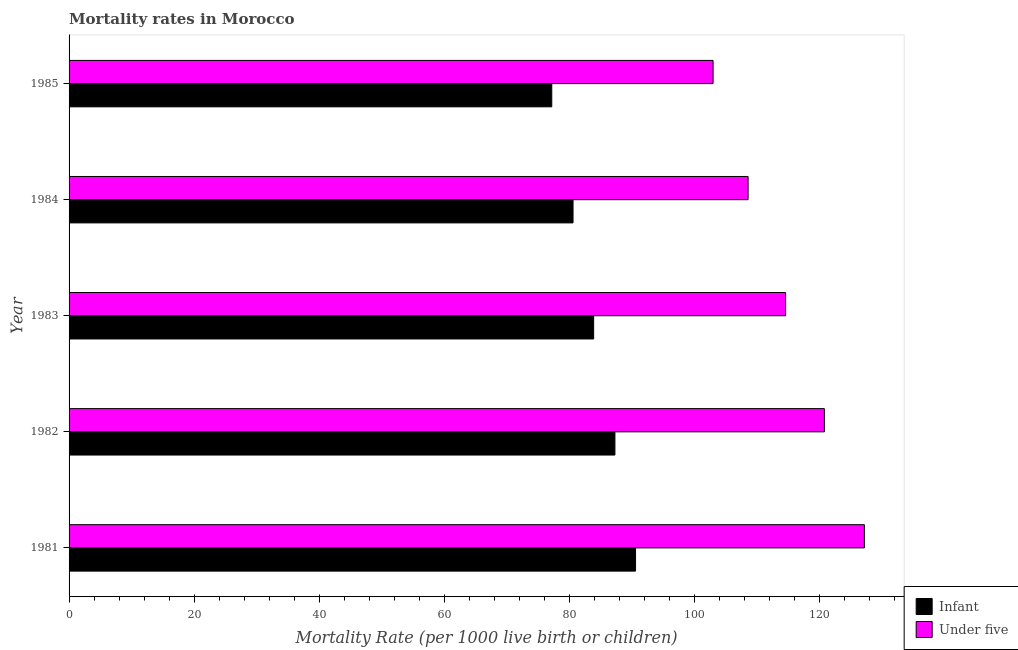Are the number of bars per tick equal to the number of legend labels?
Provide a succinct answer. Yes. Are the number of bars on each tick of the Y-axis equal?
Ensure brevity in your answer.  Yes. How many bars are there on the 2nd tick from the top?
Your response must be concise. 2. In how many cases, is the number of bars for a given year not equal to the number of legend labels?
Provide a short and direct response. 0. What is the under-5 mortality rate in 1985?
Keep it short and to the point. 103. Across all years, what is the maximum infant mortality rate?
Provide a succinct answer. 90.6. Across all years, what is the minimum infant mortality rate?
Offer a terse response. 77.2. In which year was the under-5 mortality rate minimum?
Make the answer very short. 1985. What is the total infant mortality rate in the graph?
Keep it short and to the point. 419.6. What is the difference between the infant mortality rate in 1981 and that in 1982?
Your response must be concise. 3.3. What is the difference between the under-5 mortality rate in 1984 and the infant mortality rate in 1983?
Your answer should be compact. 24.7. What is the average infant mortality rate per year?
Keep it short and to the point. 83.92. In the year 1985, what is the difference between the infant mortality rate and under-5 mortality rate?
Keep it short and to the point. -25.8. In how many years, is the infant mortality rate greater than 96 ?
Your response must be concise. 0. What is the ratio of the under-5 mortality rate in 1984 to that in 1985?
Offer a terse response. 1.05. Is the difference between the under-5 mortality rate in 1984 and 1985 greater than the difference between the infant mortality rate in 1984 and 1985?
Offer a very short reply. Yes. What is the difference between the highest and the second highest under-5 mortality rate?
Offer a very short reply. 6.4. What is the difference between the highest and the lowest under-5 mortality rate?
Keep it short and to the point. 24.2. Is the sum of the infant mortality rate in 1982 and 1985 greater than the maximum under-5 mortality rate across all years?
Provide a succinct answer. Yes. What does the 1st bar from the top in 1981 represents?
Offer a very short reply. Under five. What does the 2nd bar from the bottom in 1981 represents?
Your response must be concise. Under five. Are all the bars in the graph horizontal?
Keep it short and to the point. Yes. How many legend labels are there?
Keep it short and to the point. 2. What is the title of the graph?
Make the answer very short. Mortality rates in Morocco. Does "Male entrants" appear as one of the legend labels in the graph?
Give a very brief answer. No. What is the label or title of the X-axis?
Keep it short and to the point. Mortality Rate (per 1000 live birth or children). What is the label or title of the Y-axis?
Your answer should be very brief. Year. What is the Mortality Rate (per 1000 live birth or children) in Infant in 1981?
Your answer should be very brief. 90.6. What is the Mortality Rate (per 1000 live birth or children) of Under five in 1981?
Give a very brief answer. 127.2. What is the Mortality Rate (per 1000 live birth or children) in Infant in 1982?
Provide a succinct answer. 87.3. What is the Mortality Rate (per 1000 live birth or children) of Under five in 1982?
Make the answer very short. 120.8. What is the Mortality Rate (per 1000 live birth or children) of Infant in 1983?
Provide a succinct answer. 83.9. What is the Mortality Rate (per 1000 live birth or children) in Under five in 1983?
Your answer should be very brief. 114.6. What is the Mortality Rate (per 1000 live birth or children) of Infant in 1984?
Offer a terse response. 80.6. What is the Mortality Rate (per 1000 live birth or children) of Under five in 1984?
Your response must be concise. 108.6. What is the Mortality Rate (per 1000 live birth or children) in Infant in 1985?
Offer a very short reply. 77.2. What is the Mortality Rate (per 1000 live birth or children) in Under five in 1985?
Give a very brief answer. 103. Across all years, what is the maximum Mortality Rate (per 1000 live birth or children) of Infant?
Provide a succinct answer. 90.6. Across all years, what is the maximum Mortality Rate (per 1000 live birth or children) in Under five?
Your answer should be very brief. 127.2. Across all years, what is the minimum Mortality Rate (per 1000 live birth or children) of Infant?
Your answer should be very brief. 77.2. Across all years, what is the minimum Mortality Rate (per 1000 live birth or children) of Under five?
Keep it short and to the point. 103. What is the total Mortality Rate (per 1000 live birth or children) in Infant in the graph?
Provide a succinct answer. 419.6. What is the total Mortality Rate (per 1000 live birth or children) in Under five in the graph?
Offer a terse response. 574.2. What is the difference between the Mortality Rate (per 1000 live birth or children) of Under five in 1981 and that in 1982?
Your answer should be compact. 6.4. What is the difference between the Mortality Rate (per 1000 live birth or children) of Infant in 1981 and that in 1983?
Make the answer very short. 6.7. What is the difference between the Mortality Rate (per 1000 live birth or children) in Under five in 1981 and that in 1983?
Offer a terse response. 12.6. What is the difference between the Mortality Rate (per 1000 live birth or children) in Infant in 1981 and that in 1984?
Offer a very short reply. 10. What is the difference between the Mortality Rate (per 1000 live birth or children) in Infant in 1981 and that in 1985?
Your answer should be compact. 13.4. What is the difference between the Mortality Rate (per 1000 live birth or children) in Under five in 1981 and that in 1985?
Ensure brevity in your answer.  24.2. What is the difference between the Mortality Rate (per 1000 live birth or children) in Infant in 1982 and that in 1983?
Offer a very short reply. 3.4. What is the difference between the Mortality Rate (per 1000 live birth or children) of Under five in 1982 and that in 1983?
Your answer should be very brief. 6.2. What is the difference between the Mortality Rate (per 1000 live birth or children) in Infant in 1982 and that in 1985?
Keep it short and to the point. 10.1. What is the difference between the Mortality Rate (per 1000 live birth or children) of Under five in 1982 and that in 1985?
Offer a very short reply. 17.8. What is the difference between the Mortality Rate (per 1000 live birth or children) of Infant in 1983 and that in 1984?
Ensure brevity in your answer.  3.3. What is the difference between the Mortality Rate (per 1000 live birth or children) in Under five in 1983 and that in 1984?
Your response must be concise. 6. What is the difference between the Mortality Rate (per 1000 live birth or children) of Infant in 1983 and that in 1985?
Your response must be concise. 6.7. What is the difference between the Mortality Rate (per 1000 live birth or children) of Under five in 1983 and that in 1985?
Offer a very short reply. 11.6. What is the difference between the Mortality Rate (per 1000 live birth or children) in Infant in 1981 and the Mortality Rate (per 1000 live birth or children) in Under five in 1982?
Offer a terse response. -30.2. What is the difference between the Mortality Rate (per 1000 live birth or children) in Infant in 1981 and the Mortality Rate (per 1000 live birth or children) in Under five in 1985?
Provide a short and direct response. -12.4. What is the difference between the Mortality Rate (per 1000 live birth or children) of Infant in 1982 and the Mortality Rate (per 1000 live birth or children) of Under five in 1983?
Ensure brevity in your answer.  -27.3. What is the difference between the Mortality Rate (per 1000 live birth or children) of Infant in 1982 and the Mortality Rate (per 1000 live birth or children) of Under five in 1984?
Provide a succinct answer. -21.3. What is the difference between the Mortality Rate (per 1000 live birth or children) of Infant in 1982 and the Mortality Rate (per 1000 live birth or children) of Under five in 1985?
Your answer should be compact. -15.7. What is the difference between the Mortality Rate (per 1000 live birth or children) of Infant in 1983 and the Mortality Rate (per 1000 live birth or children) of Under five in 1984?
Make the answer very short. -24.7. What is the difference between the Mortality Rate (per 1000 live birth or children) of Infant in 1983 and the Mortality Rate (per 1000 live birth or children) of Under five in 1985?
Your answer should be very brief. -19.1. What is the difference between the Mortality Rate (per 1000 live birth or children) in Infant in 1984 and the Mortality Rate (per 1000 live birth or children) in Under five in 1985?
Offer a very short reply. -22.4. What is the average Mortality Rate (per 1000 live birth or children) of Infant per year?
Ensure brevity in your answer.  83.92. What is the average Mortality Rate (per 1000 live birth or children) of Under five per year?
Give a very brief answer. 114.84. In the year 1981, what is the difference between the Mortality Rate (per 1000 live birth or children) of Infant and Mortality Rate (per 1000 live birth or children) of Under five?
Provide a short and direct response. -36.6. In the year 1982, what is the difference between the Mortality Rate (per 1000 live birth or children) of Infant and Mortality Rate (per 1000 live birth or children) of Under five?
Ensure brevity in your answer.  -33.5. In the year 1983, what is the difference between the Mortality Rate (per 1000 live birth or children) in Infant and Mortality Rate (per 1000 live birth or children) in Under five?
Keep it short and to the point. -30.7. In the year 1984, what is the difference between the Mortality Rate (per 1000 live birth or children) of Infant and Mortality Rate (per 1000 live birth or children) of Under five?
Offer a terse response. -28. In the year 1985, what is the difference between the Mortality Rate (per 1000 live birth or children) of Infant and Mortality Rate (per 1000 live birth or children) of Under five?
Your answer should be very brief. -25.8. What is the ratio of the Mortality Rate (per 1000 live birth or children) in Infant in 1981 to that in 1982?
Your answer should be compact. 1.04. What is the ratio of the Mortality Rate (per 1000 live birth or children) in Under five in 1981 to that in 1982?
Offer a very short reply. 1.05. What is the ratio of the Mortality Rate (per 1000 live birth or children) of Infant in 1981 to that in 1983?
Offer a very short reply. 1.08. What is the ratio of the Mortality Rate (per 1000 live birth or children) in Under five in 1981 to that in 1983?
Offer a terse response. 1.11. What is the ratio of the Mortality Rate (per 1000 live birth or children) of Infant in 1981 to that in 1984?
Keep it short and to the point. 1.12. What is the ratio of the Mortality Rate (per 1000 live birth or children) in Under five in 1981 to that in 1984?
Give a very brief answer. 1.17. What is the ratio of the Mortality Rate (per 1000 live birth or children) in Infant in 1981 to that in 1985?
Give a very brief answer. 1.17. What is the ratio of the Mortality Rate (per 1000 live birth or children) in Under five in 1981 to that in 1985?
Offer a very short reply. 1.24. What is the ratio of the Mortality Rate (per 1000 live birth or children) in Infant in 1982 to that in 1983?
Make the answer very short. 1.04. What is the ratio of the Mortality Rate (per 1000 live birth or children) of Under five in 1982 to that in 1983?
Your response must be concise. 1.05. What is the ratio of the Mortality Rate (per 1000 live birth or children) in Infant in 1982 to that in 1984?
Keep it short and to the point. 1.08. What is the ratio of the Mortality Rate (per 1000 live birth or children) of Under five in 1982 to that in 1984?
Your answer should be compact. 1.11. What is the ratio of the Mortality Rate (per 1000 live birth or children) of Infant in 1982 to that in 1985?
Offer a terse response. 1.13. What is the ratio of the Mortality Rate (per 1000 live birth or children) of Under five in 1982 to that in 1985?
Offer a very short reply. 1.17. What is the ratio of the Mortality Rate (per 1000 live birth or children) of Infant in 1983 to that in 1984?
Your response must be concise. 1.04. What is the ratio of the Mortality Rate (per 1000 live birth or children) of Under five in 1983 to that in 1984?
Give a very brief answer. 1.06. What is the ratio of the Mortality Rate (per 1000 live birth or children) in Infant in 1983 to that in 1985?
Offer a terse response. 1.09. What is the ratio of the Mortality Rate (per 1000 live birth or children) in Under five in 1983 to that in 1985?
Your answer should be very brief. 1.11. What is the ratio of the Mortality Rate (per 1000 live birth or children) in Infant in 1984 to that in 1985?
Make the answer very short. 1.04. What is the ratio of the Mortality Rate (per 1000 live birth or children) in Under five in 1984 to that in 1985?
Offer a very short reply. 1.05. What is the difference between the highest and the second highest Mortality Rate (per 1000 live birth or children) of Infant?
Keep it short and to the point. 3.3. What is the difference between the highest and the second highest Mortality Rate (per 1000 live birth or children) of Under five?
Offer a terse response. 6.4. What is the difference between the highest and the lowest Mortality Rate (per 1000 live birth or children) of Under five?
Your response must be concise. 24.2. 